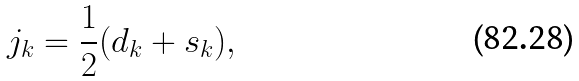<formula> <loc_0><loc_0><loc_500><loc_500>j _ { k } = \frac { 1 } { 2 } ( d _ { k } + s _ { k } ) ,</formula> 